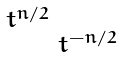Convert formula to latex. <formula><loc_0><loc_0><loc_500><loc_500>\begin{smallmatrix} t ^ { n / 2 } & \\ & t ^ { - n / 2 } \end{smallmatrix}</formula> 